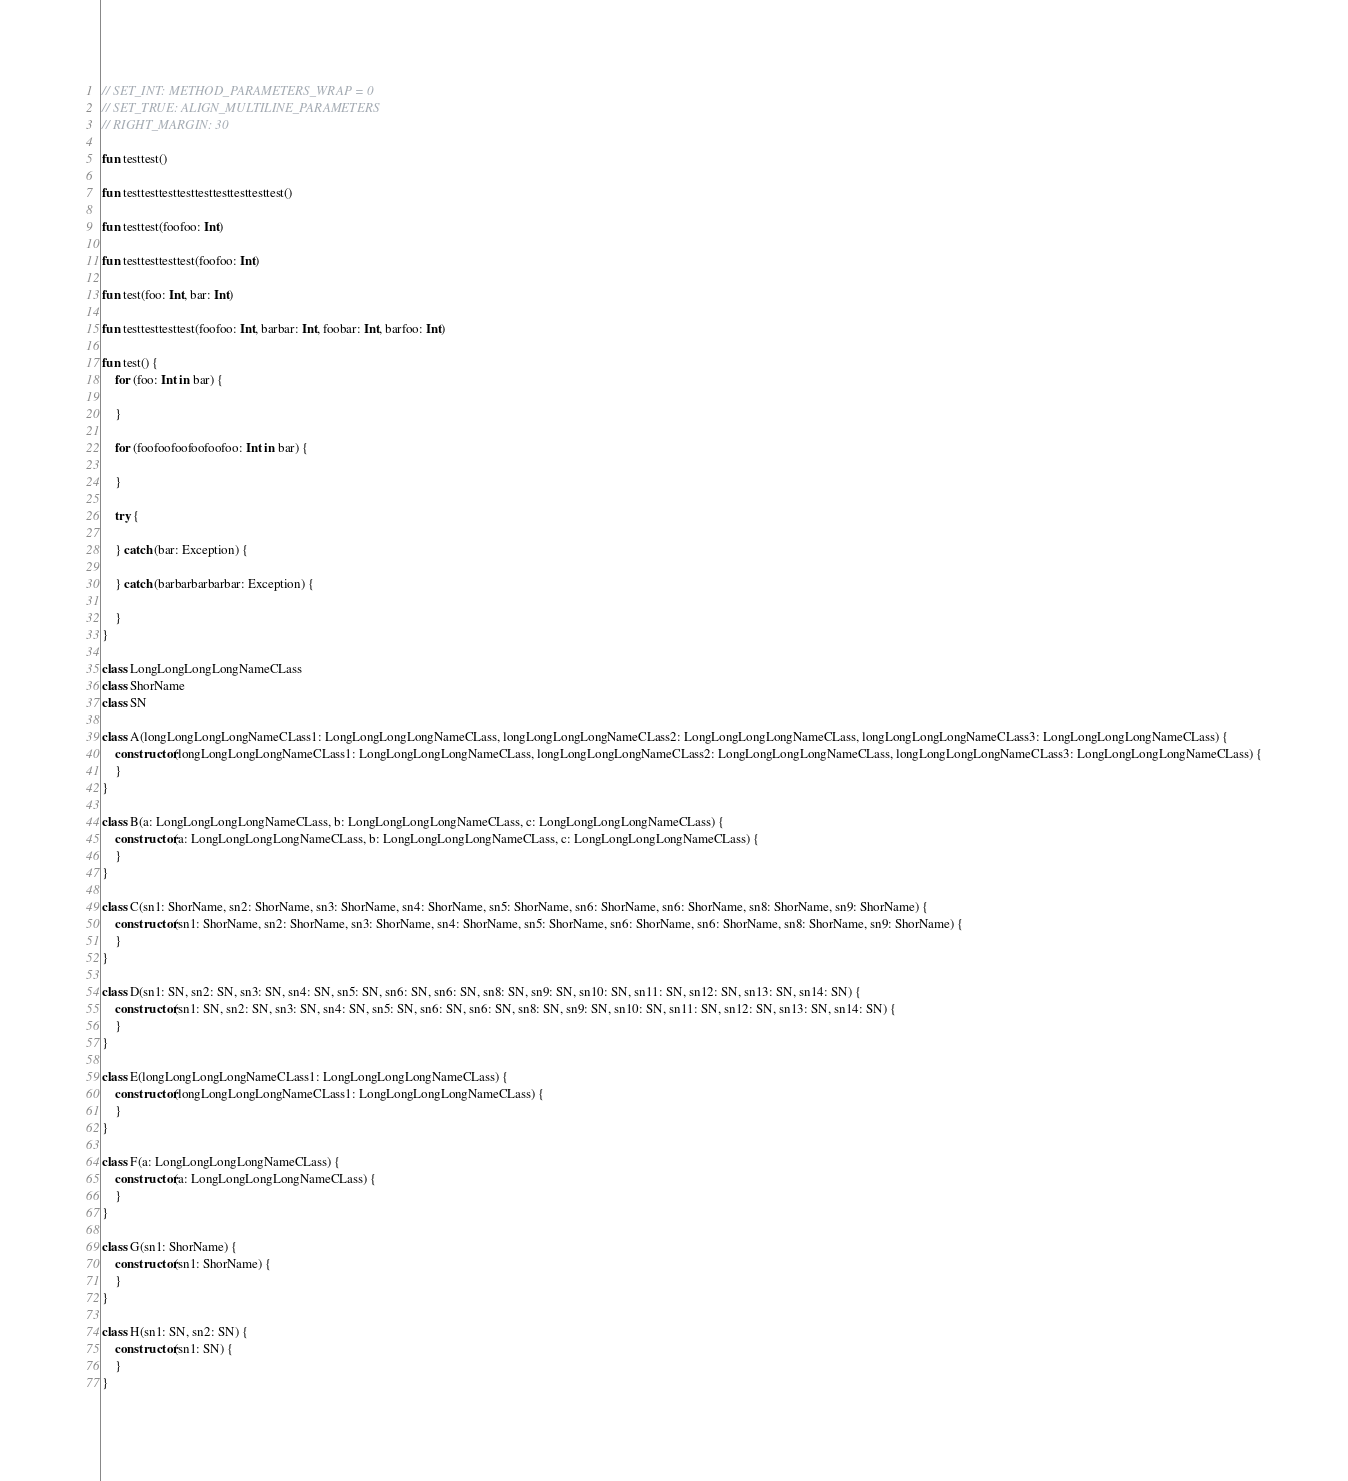<code> <loc_0><loc_0><loc_500><loc_500><_Kotlin_>// SET_INT: METHOD_PARAMETERS_WRAP = 0
// SET_TRUE: ALIGN_MULTILINE_PARAMETERS
// RIGHT_MARGIN: 30

fun testtest()

fun testtesttesttesttesttesttesttesttest()

fun testtest(foofoo: Int)

fun testtesttesttest(foofoo: Int)

fun test(foo: Int, bar: Int)

fun testtesttesttest(foofoo: Int, barbar: Int, foobar: Int, barfoo: Int)

fun test() {
    for (foo: Int in bar) {

    }

    for (foofoofoofoofoofoo: Int in bar) {

    }

    try {

    } catch (bar: Exception) {

    } catch (barbarbarbarbar: Exception) {

    }
}

class LongLongLongLongNameCLass
class ShorName
class SN

class A(longLongLongLongNameCLass1: LongLongLongLongNameCLass, longLongLongLongNameCLass2: LongLongLongLongNameCLass, longLongLongLongNameCLass3: LongLongLongLongNameCLass) {
    constructor(longLongLongLongNameCLass1: LongLongLongLongNameCLass, longLongLongLongNameCLass2: LongLongLongLongNameCLass, longLongLongLongNameCLass3: LongLongLongLongNameCLass) {
    }
}

class B(a: LongLongLongLongNameCLass, b: LongLongLongLongNameCLass, c: LongLongLongLongNameCLass) {
    constructor(a: LongLongLongLongNameCLass, b: LongLongLongLongNameCLass, c: LongLongLongLongNameCLass) {
    }
}

class C(sn1: ShorName, sn2: ShorName, sn3: ShorName, sn4: ShorName, sn5: ShorName, sn6: ShorName, sn6: ShorName, sn8: ShorName, sn9: ShorName) {
    constructor(sn1: ShorName, sn2: ShorName, sn3: ShorName, sn4: ShorName, sn5: ShorName, sn6: ShorName, sn6: ShorName, sn8: ShorName, sn9: ShorName) {
    }
}

class D(sn1: SN, sn2: SN, sn3: SN, sn4: SN, sn5: SN, sn6: SN, sn6: SN, sn8: SN, sn9: SN, sn10: SN, sn11: SN, sn12: SN, sn13: SN, sn14: SN) {
    constructor(sn1: SN, sn2: SN, sn3: SN, sn4: SN, sn5: SN, sn6: SN, sn6: SN, sn8: SN, sn9: SN, sn10: SN, sn11: SN, sn12: SN, sn13: SN, sn14: SN) {
    }
}

class E(longLongLongLongNameCLass1: LongLongLongLongNameCLass) {
    constructor(longLongLongLongNameCLass1: LongLongLongLongNameCLass) {
    }
}

class F(a: LongLongLongLongNameCLass) {
    constructor(a: LongLongLongLongNameCLass) {
    }
}

class G(sn1: ShorName) {
    constructor(sn1: ShorName) {
    }
}

class H(sn1: SN, sn2: SN) {
    constructor(sn1: SN) {
    }
}
</code> 